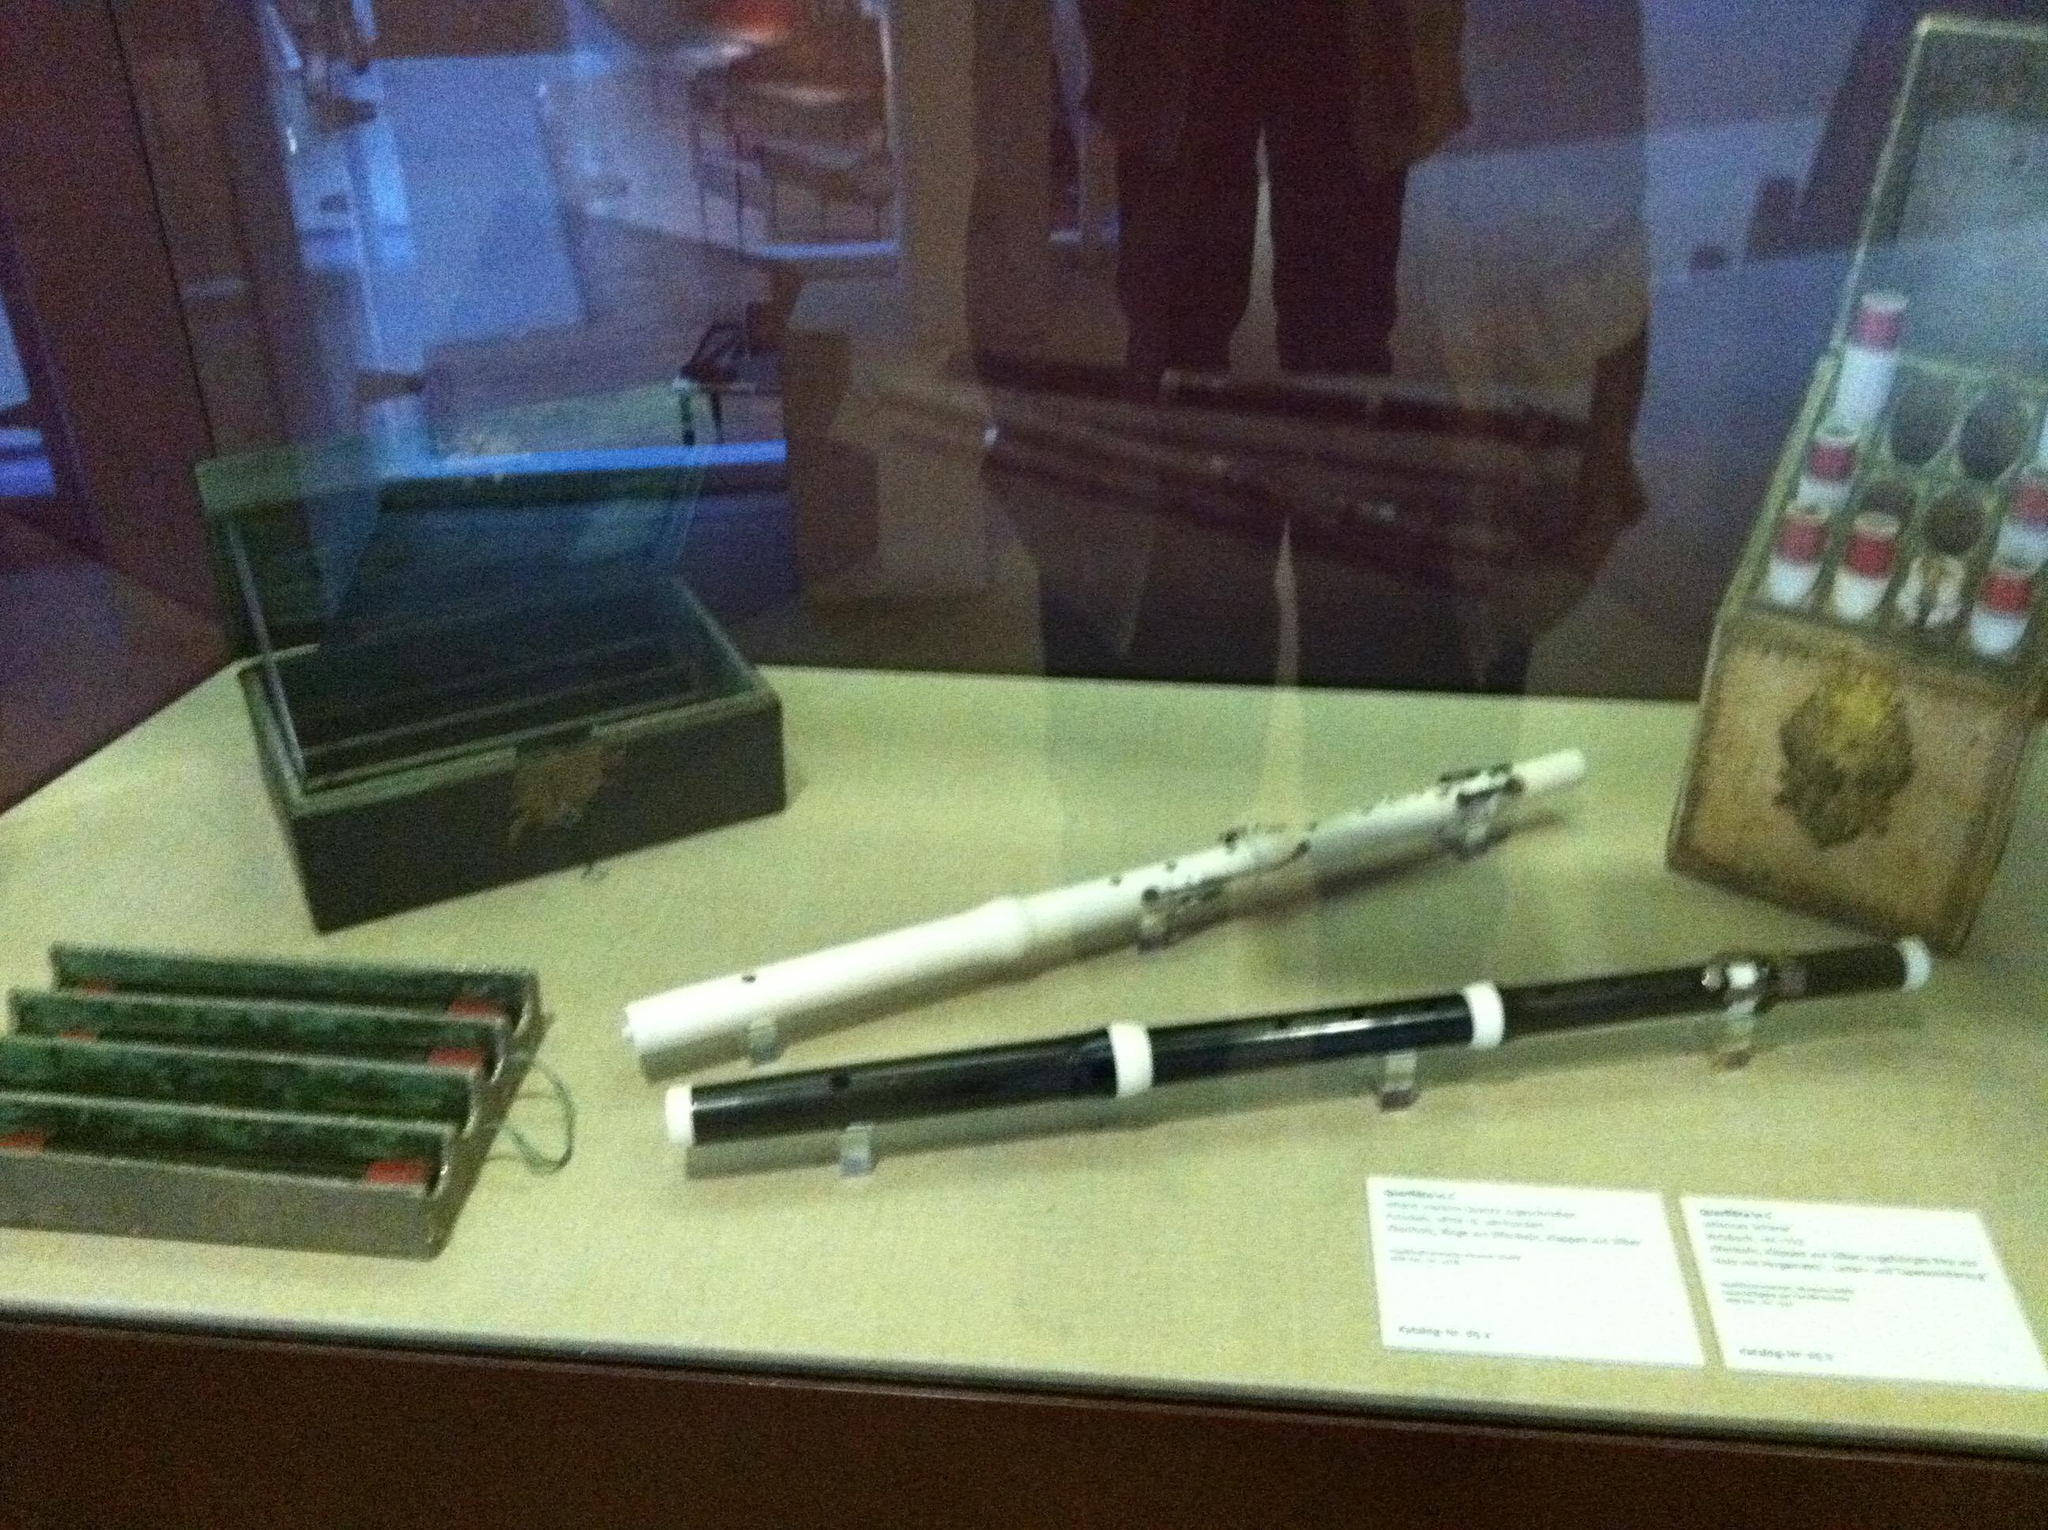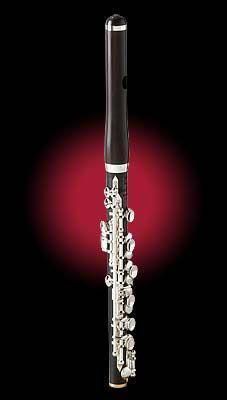The first image is the image on the left, the second image is the image on the right. For the images displayed, is the sentence "The right image shows a small wind instrument decorated with a wrapped garland and posed with 2 smaller sections and a carved wood carrying case." factually correct? Answer yes or no. No. The first image is the image on the left, the second image is the image on the right. For the images shown, is this caption "There are two instruments in the image on the left." true? Answer yes or no. Yes. 